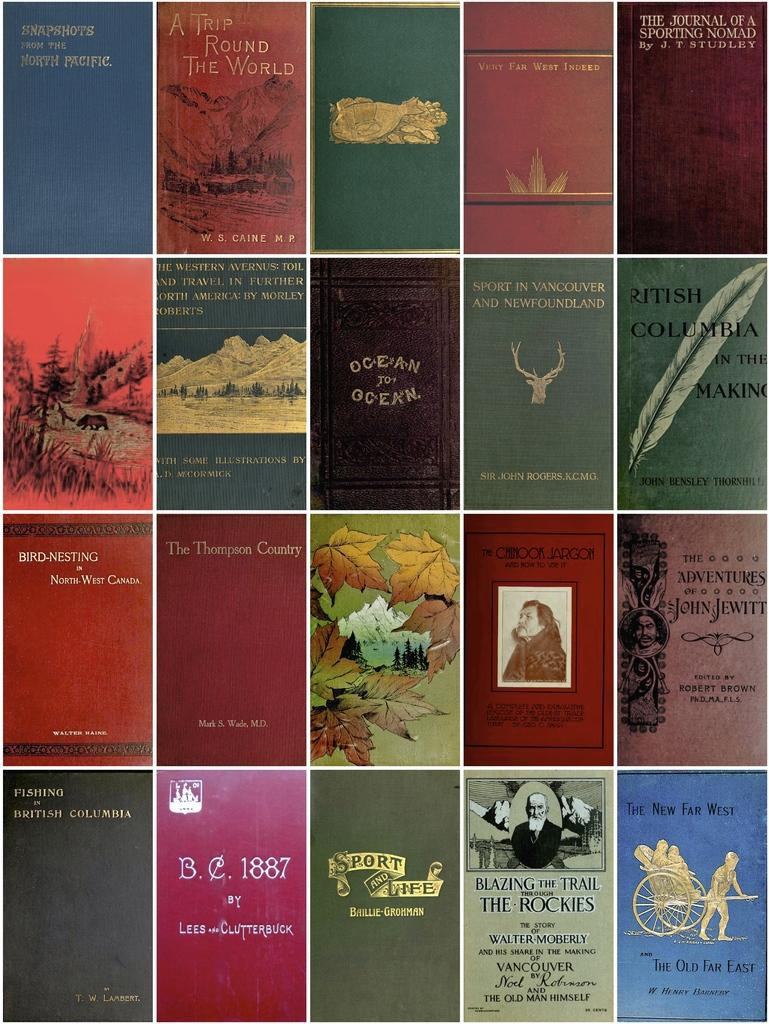<image>
Create a compact narrative representing the image presented. Twenty book covers are shown featuring writers such as Walter Raine and John Bensley Thornhill. 